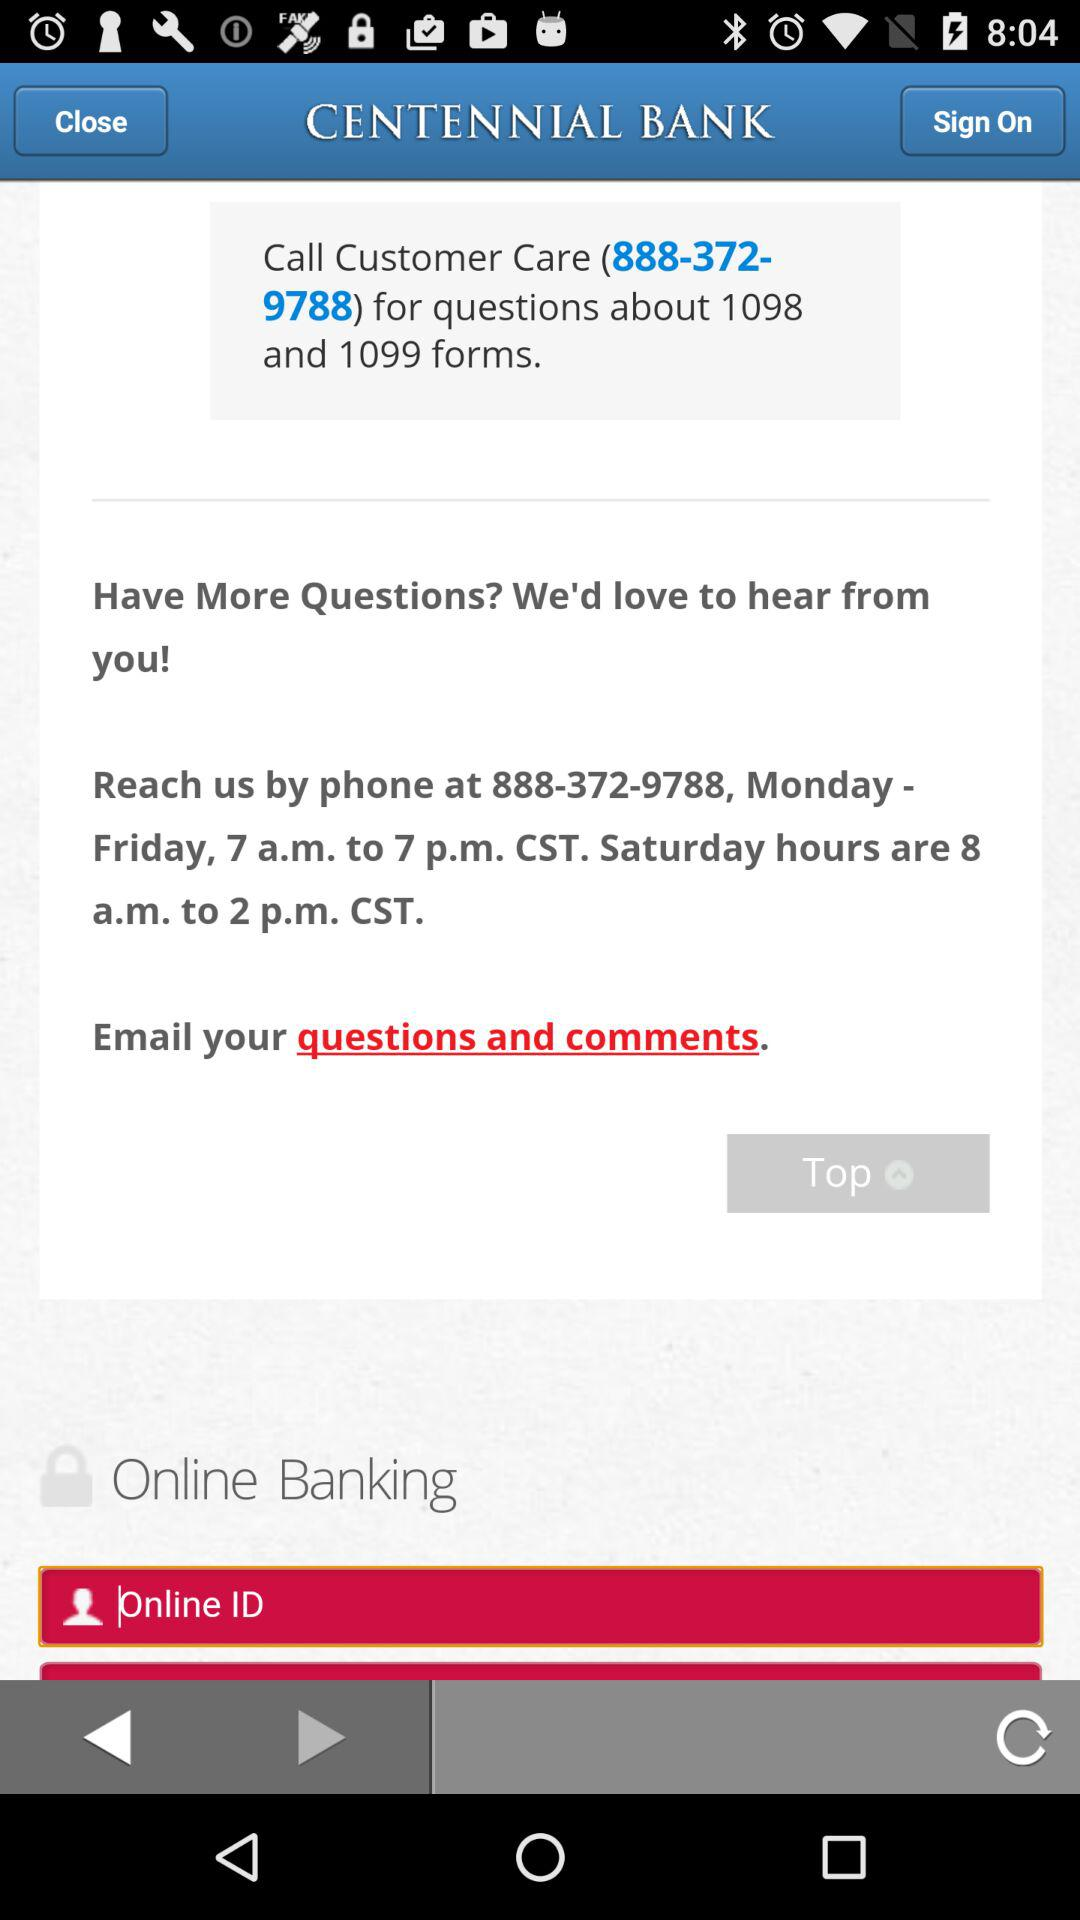What is the customer care number? The number is "888-372-9788". 